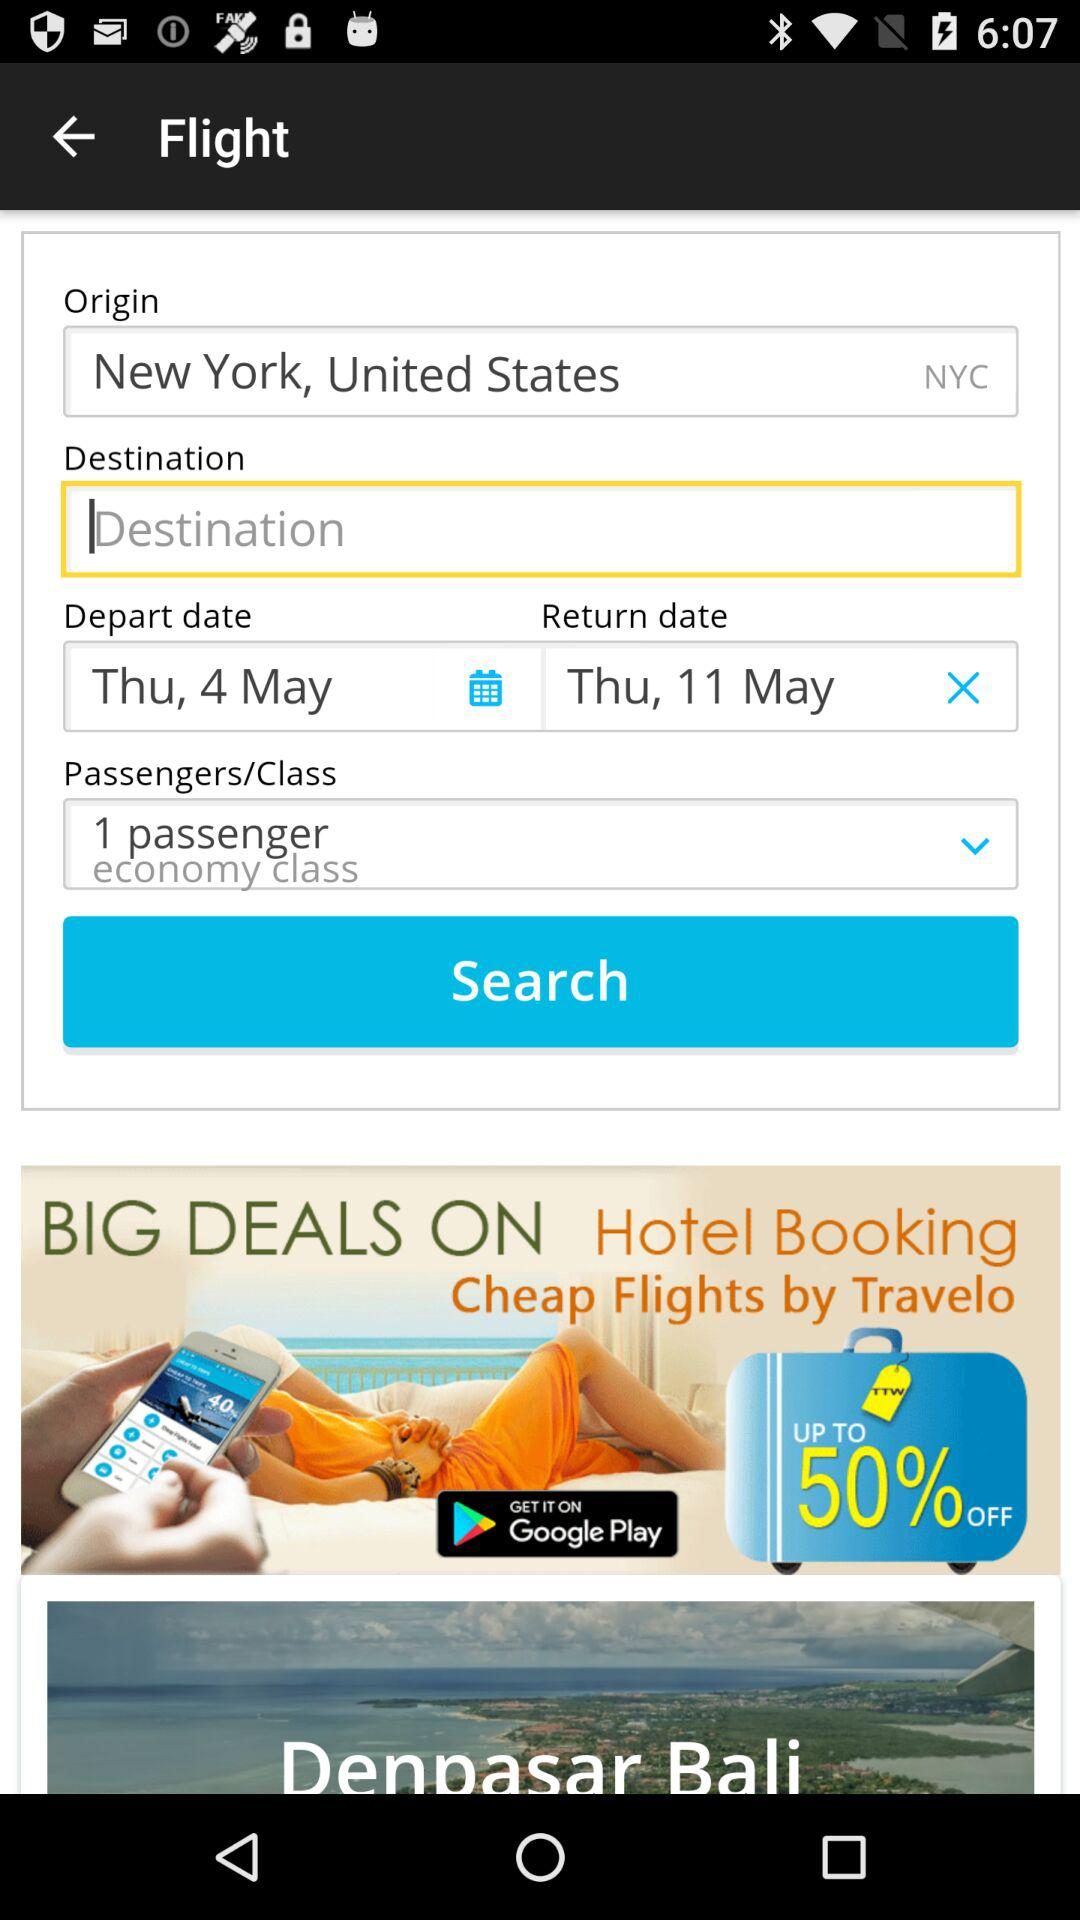What are the travel dates for this booking? The travel dates for this booking are from Thursday, 4th May to Thursday, 11th May. 